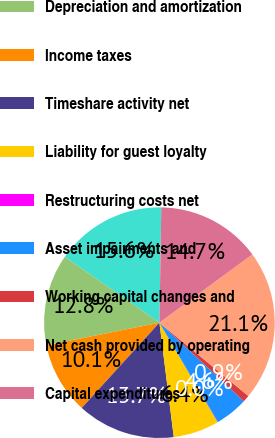<chart> <loc_0><loc_0><loc_500><loc_500><pie_chart><fcel>Net income (loss)<fcel>Depreciation and amortization<fcel>Income taxes<fcel>Timeshare activity net<fcel>Liability for guest loyalty<fcel>Restructuring costs net<fcel>Asset impairments and<fcel>Working capital changes and<fcel>Net cash provided by operating<fcel>Capital expenditures<nl><fcel>15.58%<fcel>12.83%<fcel>10.09%<fcel>13.75%<fcel>6.44%<fcel>0.04%<fcel>4.61%<fcel>0.95%<fcel>21.06%<fcel>14.66%<nl></chart> 